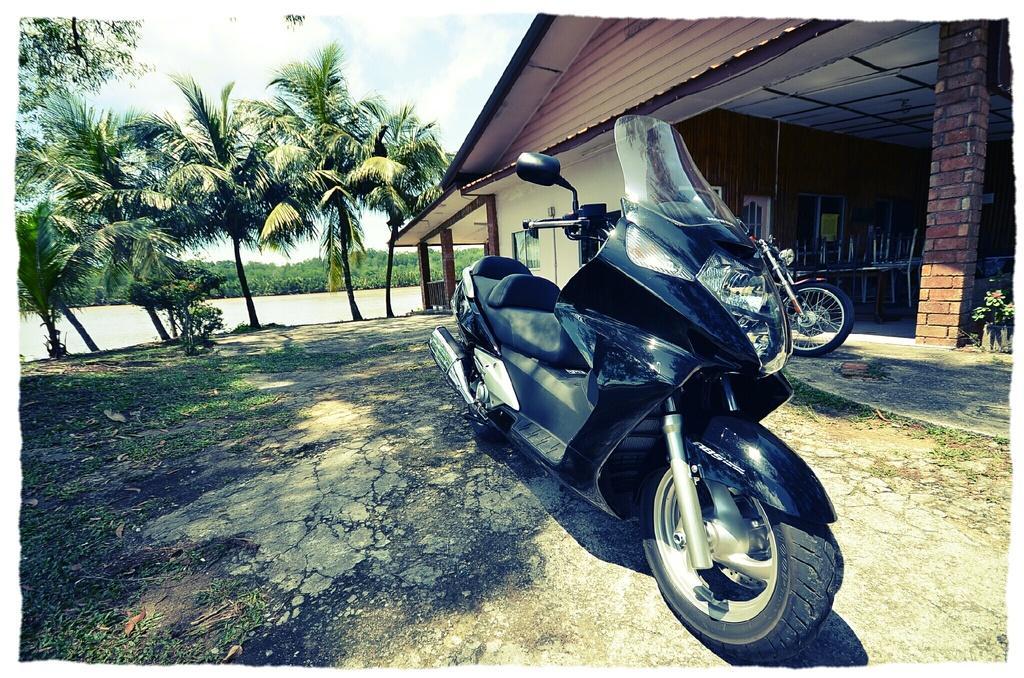How would you summarize this image in a sentence or two? In the image we can see there are two bikes. We can even see there are chairs and brick pole. Here we can see trees, water and a cloudy sky. We can even see the grass and the house. 